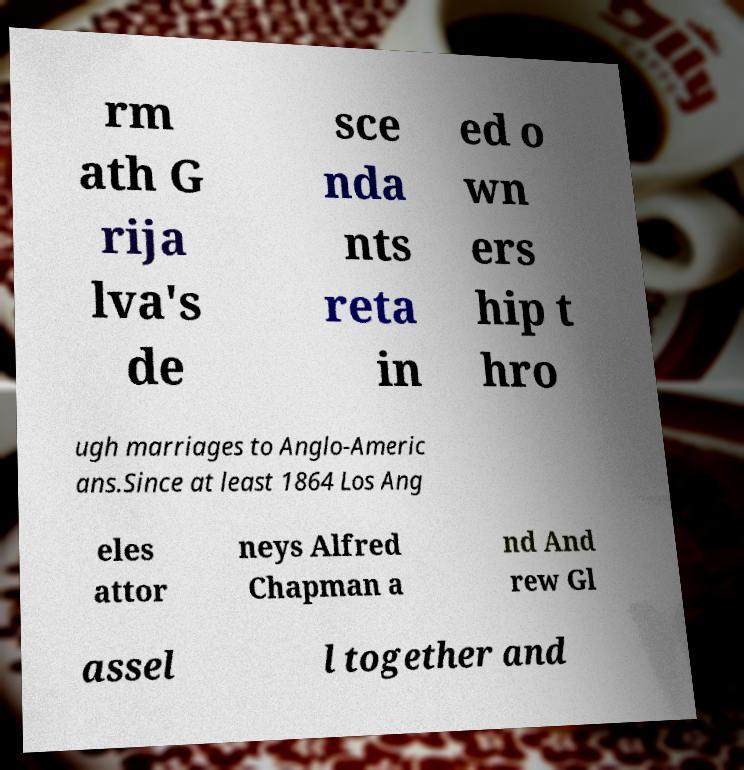For documentation purposes, I need the text within this image transcribed. Could you provide that? rm ath G rija lva's de sce nda nts reta in ed o wn ers hip t hro ugh marriages to Anglo-Americ ans.Since at least 1864 Los Ang eles attor neys Alfred Chapman a nd And rew Gl assel l together and 